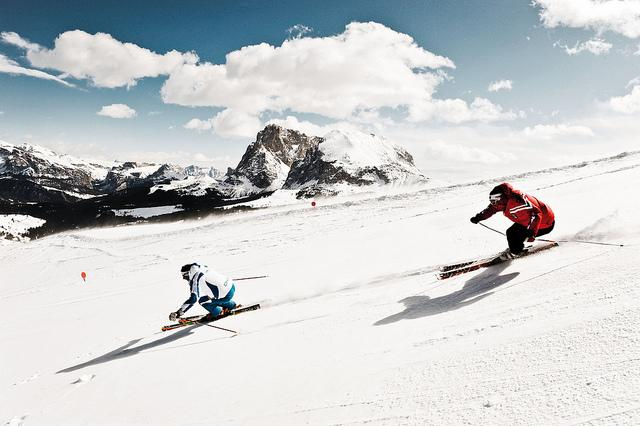What kind of skis are the two using in this mountain range? Please explain your reasoning. racing. The skiiers are going very fast down the hill. one skiier is in the lead. 